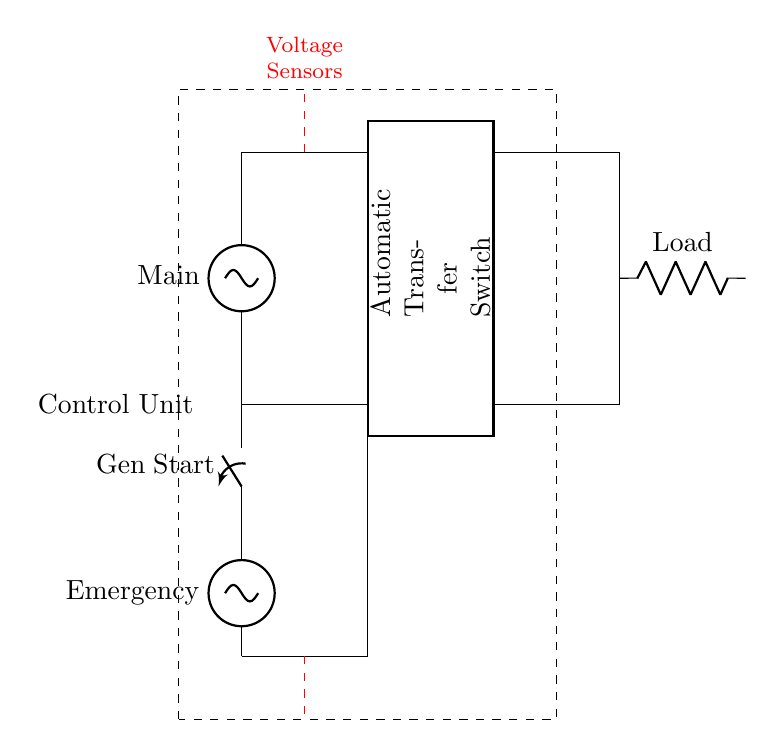What type of switch is used for generator starting? The circuit diagram shows an "opening switch" labeled as "Gen Start", indicating that this switch is used to start the emergency generator.
Answer: opening switch What do the dashed lines represent in the control unit? The dashed red lines indicate voltage sensors connected at both the main power and emergency generator sides, essential for monitoring voltage levels.
Answer: Voltage Sensors How many inputs does the automatic transfer switch have? The automatic transfer switch has two main inputs: one from the main power supply and one from the emergency generator, as indicated in the diagram.
Answer: two What is the labeled load in this circuit? The load is clearly marked as "Load" in the circuit, receiving power from the automatic transfer switch when either the main power or emergency generator is supplying energy.
Answer: Load Which component ensures that the circuit can switch power sources? The automatic transfer switch is the component responsible for automatically transferring the load between the main power supply and the emergency generator, enabling seamless service during outages.
Answer: Automatic Transfer Switch During a power outage, which supply does the control unit prioritize? The control unit activates the emergency generator supply when the main supply is interrupted, as indicated by the connections showing an action to switch from main supply to emergency.
Answer: Emergency Generator What is the primary function of the control unit in this circuit? The control unit monitors both supplies using sensors and manages the operation of the automatic transfer switch to ensure the load remains powered at all times.
Answer: Manage power switching 